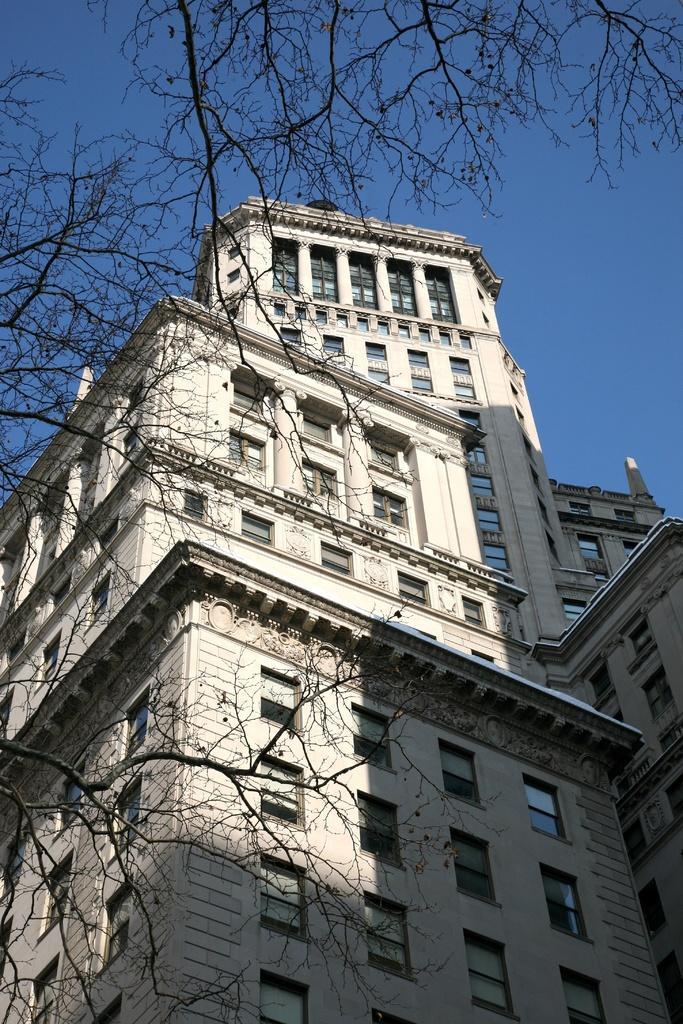How would you summarize this image in a sentence or two? In this image I can see a multi story building. On the left hand side of the image I can see a dried tree. At the top of the image I can see the sky. 